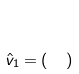<formula> <loc_0><loc_0><loc_500><loc_500>\hat { v } _ { 1 } = ( \begin{matrix} 2 \\ 1 \end{matrix} )</formula> 